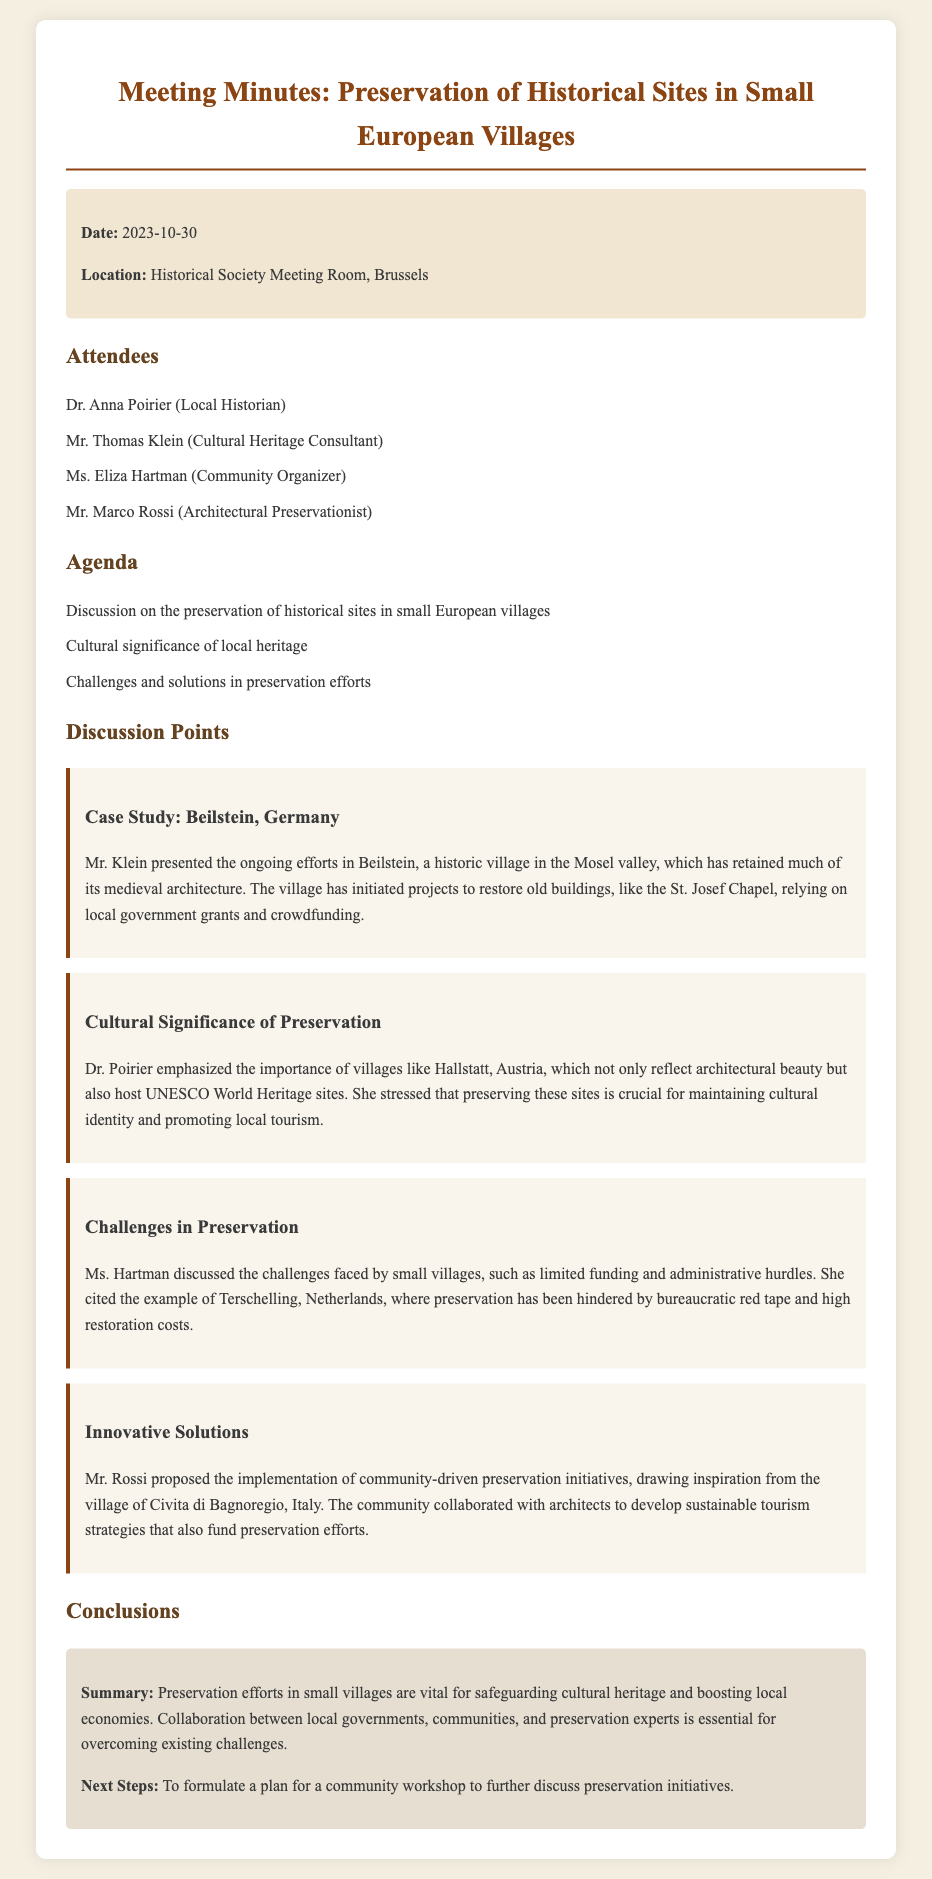What is the date of the meeting? The date provided in the document is noted under the info section as 2023-10-30.
Answer: 2023-10-30 Who is the local historian attending the meeting? The local historian listed in the attendees section is Dr. Anna Poirier.
Answer: Dr. Anna Poirier What village was used as a case study during the meeting? Mr. Klein presented on Beilstein, Germany, as the case study in the discussion points.
Answer: Beilstein, Germany Which UNESCO World Heritage site was mentioned during the discussion? Dr. Poirier highlighted Hallstatt, Austria, which is known for its UNESCO World Heritage site status.
Answer: Hallstatt, Austria What challenges were cited related to preservation in small villages? Ms. Hartman mentioned limited funding and administrative hurdles as key challenges faced.
Answer: Limited funding and administrative hurdles What innovative preservation solution was proposed? Mr. Rossi proposed community-driven preservation initiatives inspired by Civita di Bagnoregio, Italy.
Answer: Community-driven preservation initiatives What is the overall conclusion about preservation efforts? The summary states that preservation efforts are vital for safeguarding cultural heritage and boosting local economies.
Answer: Vital for safeguarding cultural heritage and boosting local economies What are the next steps proposed in the meeting? The next steps involve formulating a plan for a community workshop on preservation initiatives.
Answer: Community workshop plan 